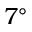<formula> <loc_0><loc_0><loc_500><loc_500>7 ^ { \circ }</formula> 